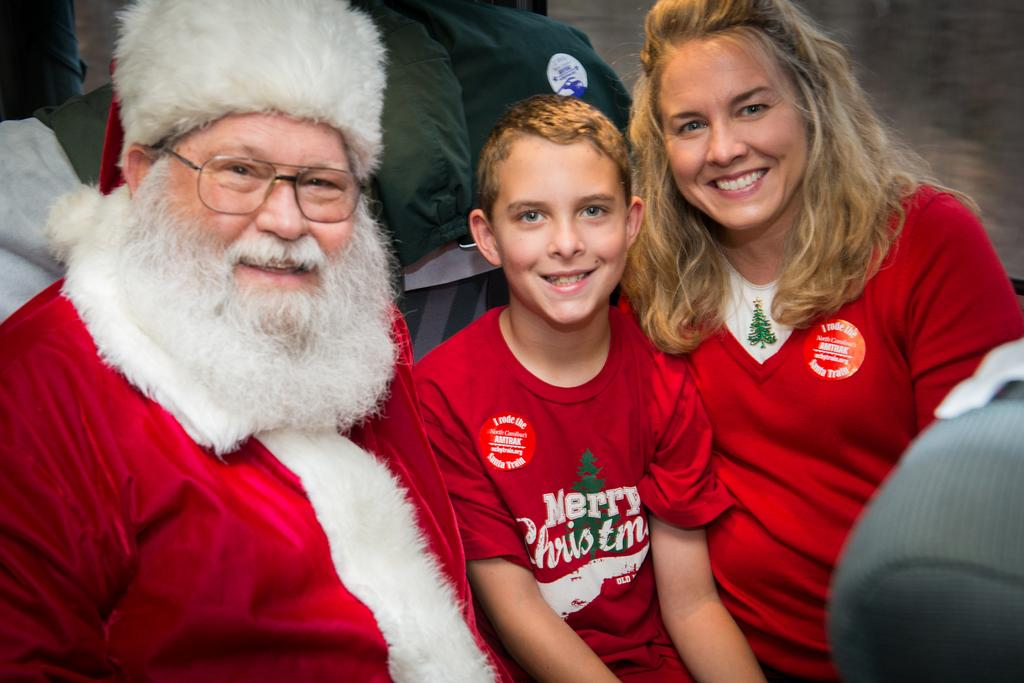<image>
Summarize the visual content of the image. A young man sitting between Santa Claus and a woman wearing a red Merry Christmas shirt. 